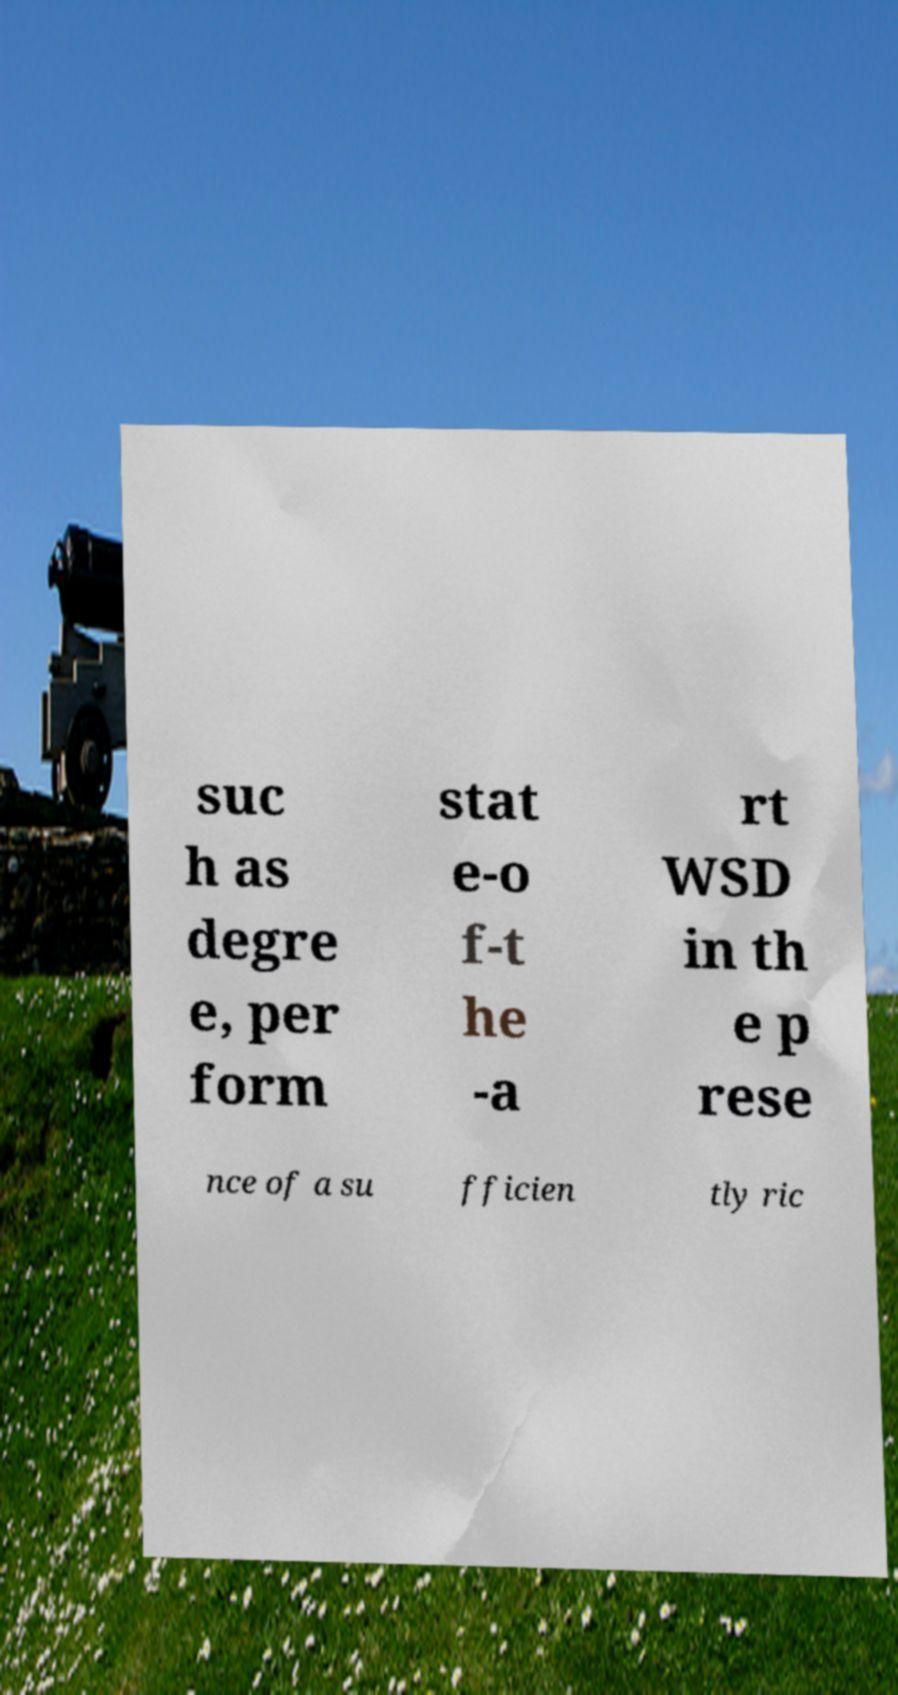Could you assist in decoding the text presented in this image and type it out clearly? suc h as degre e, per form stat e-o f-t he -a rt WSD in th e p rese nce of a su fficien tly ric 